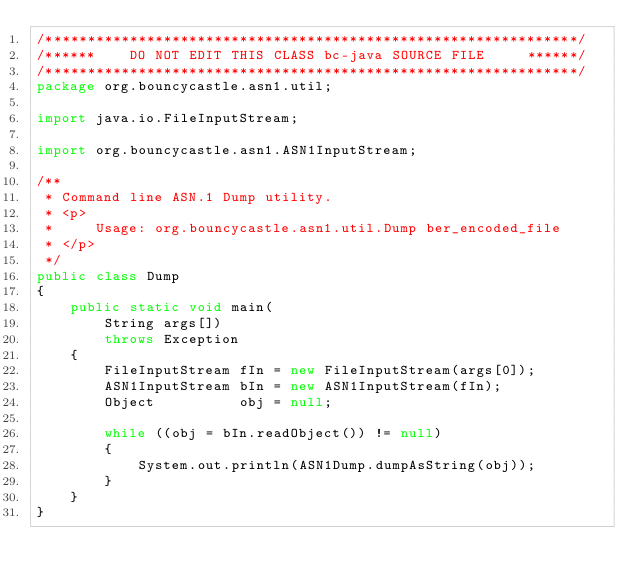Convert code to text. <code><loc_0><loc_0><loc_500><loc_500><_Java_>/***************************************************************/
/******    DO NOT EDIT THIS CLASS bc-java SOURCE FILE     ******/
/***************************************************************/
package org.bouncycastle.asn1.util;

import java.io.FileInputStream;

import org.bouncycastle.asn1.ASN1InputStream;

/**
 * Command line ASN.1 Dump utility.
 * <p>
 *     Usage: org.bouncycastle.asn1.util.Dump ber_encoded_file
 * </p>
 */
public class Dump
{
    public static void main(
        String args[])
        throws Exception
    {
        FileInputStream fIn = new FileInputStream(args[0]);
        ASN1InputStream bIn = new ASN1InputStream(fIn);
        Object          obj = null;

        while ((obj = bIn.readObject()) != null)
        {
            System.out.println(ASN1Dump.dumpAsString(obj));
        }
    }
}
</code> 